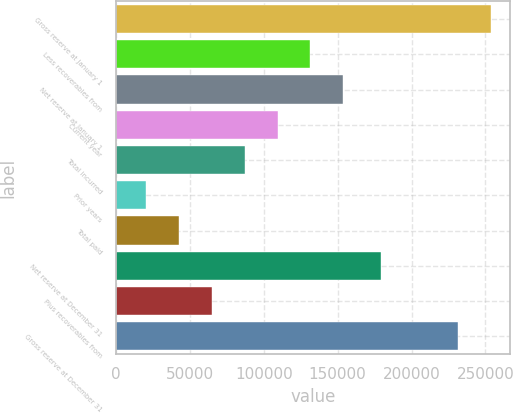Convert chart to OTSL. <chart><loc_0><loc_0><loc_500><loc_500><bar_chart><fcel>Gross reserve at January 1<fcel>Less recoverables from<fcel>Net reserve at January 1<fcel>Current year<fcel>Total incurred<fcel>Prior years<fcel>Total paid<fcel>Net reserve at December 31<fcel>Plus recoverables from<fcel>Gross reserve at December 31<nl><fcel>253684<fcel>131566<fcel>153756<fcel>109375<fcel>87185.3<fcel>20615<fcel>42805.1<fcel>179071<fcel>64995.2<fcel>231494<nl></chart> 